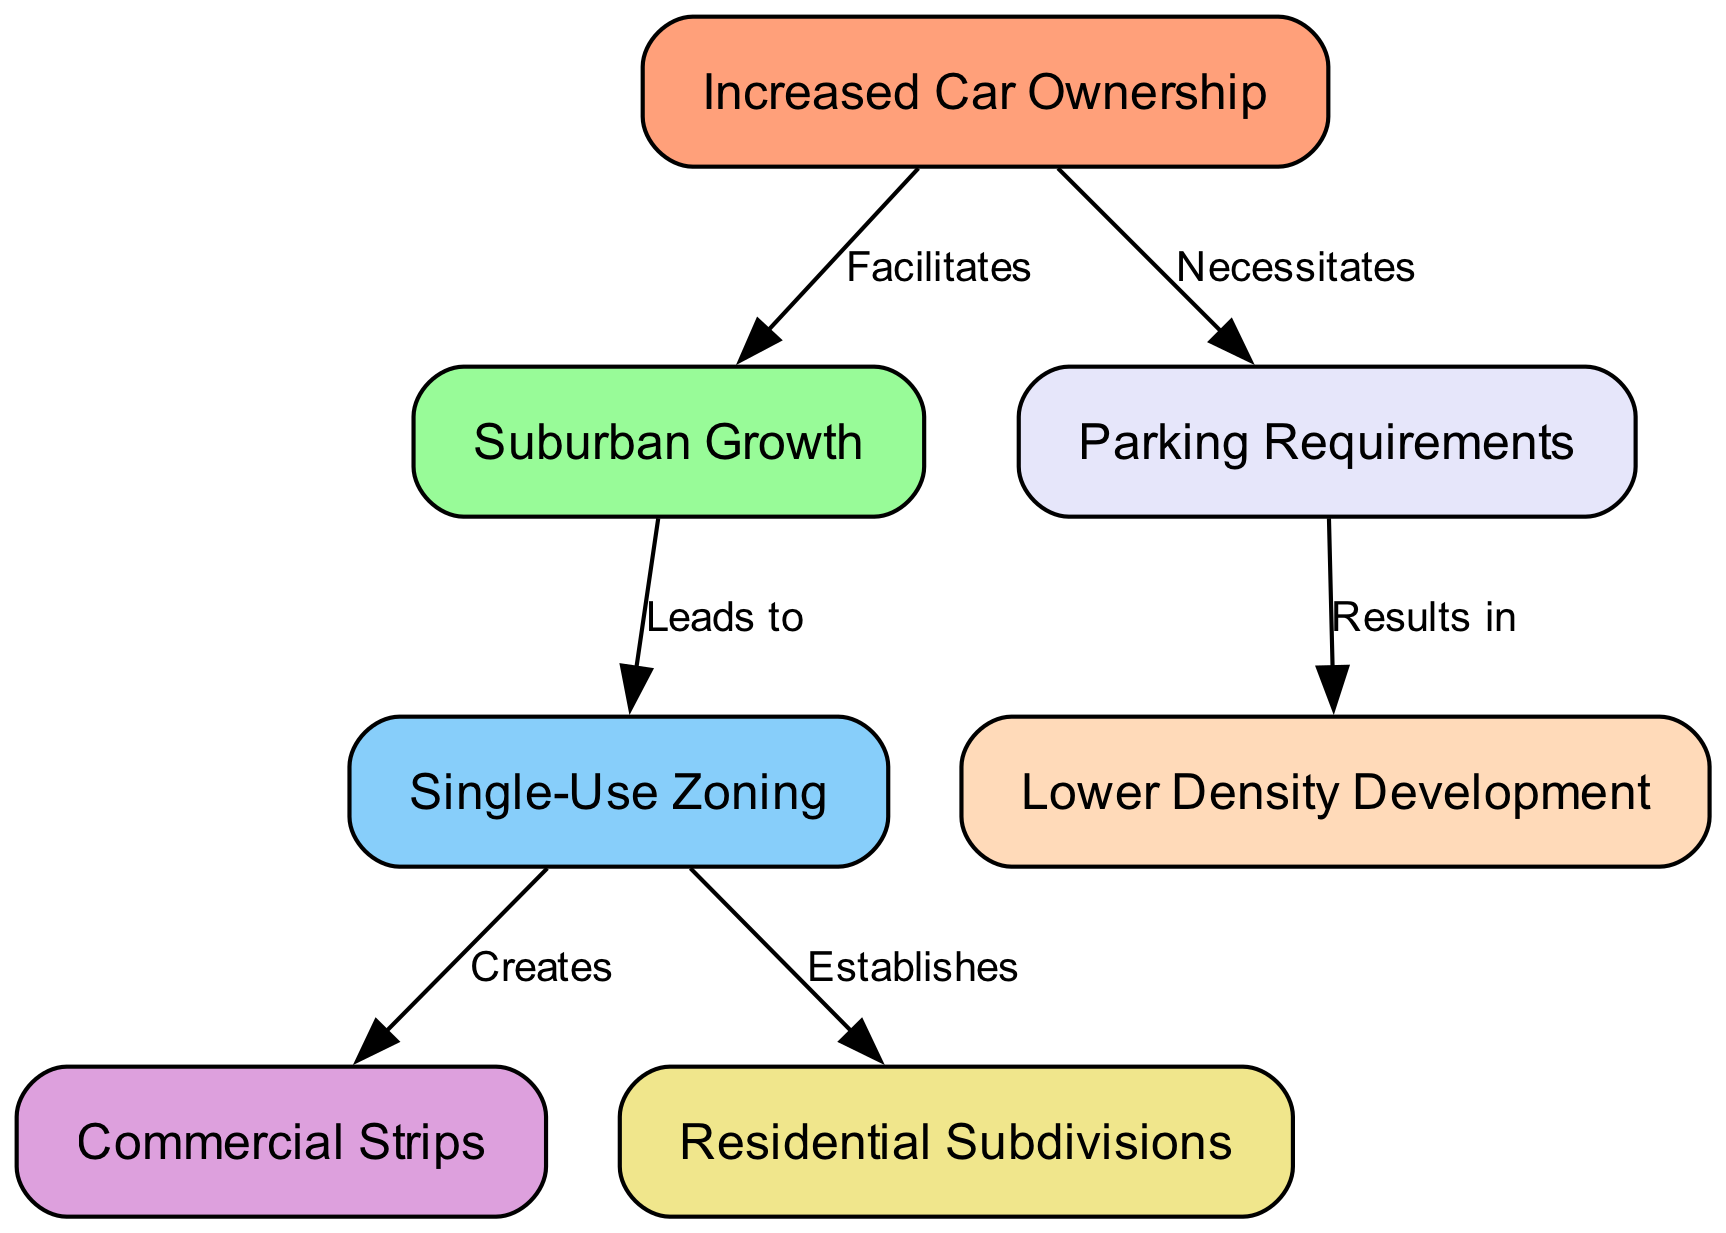What is the last node in the diagram? The last node is determined by tracing the directed edges starting from the first node. The edges from "Increased Car Ownership" lead to "Suburban Growth" which has edges leading to "Single-Use Zoning." This establishes connections to "Commercial Strips" and "Residential Subdivisions," but there's a separate connection from "Increased Car Ownership" to "Parking Requirements," which then leads to "Lower Density Development," making "Lower Density Development" the last node.
Answer: Lower Density Development How many nodes are there in the diagram? By counting the listed nodes in the data, we find the nodes: "Increased Car Ownership," "Suburban Growth," "Single-Use Zoning," "Commercial Strips," "Residential Subdivisions," "Parking Requirements," and "Lower Density Development." This totals up to seven distinct nodes.
Answer: 7 What type of zoning is created due to Single-Use Zoning? The connection from "Single-Use Zoning" has two edges leading to "Commercial Strips" and "Residential Subdivisions." Therefore, it creates both, but in this case, the question asks for one specific type. Since "Commercial Strips" is specifically mentioned as being created, it is the answer.
Answer: Commercial Strips What does increased car ownership facilitate? Starting from the node "Increased Car Ownership," there is a directed edge to the node "Suburban Growth," indicating that increased car ownership facilitates suburban growth directly.
Answer: Suburban Growth What results from the parking requirements? Tracing the edge leading from "Parking Requirements," we see it connects to "Lower Density Development," indicating that parking requirements result in this kind of development in the area influenced.
Answer: Lower Density Development Which node is linked by the most edges? Examining the connections, "Single-Use Zoning" connects to both "Commercial Strips" and "Residential Subdivisions," which signifies it has the most outgoing connections (or edges) in this diagram.
Answer: Single-Use Zoning What is established by Single-Use Zoning? Looking at the edges from "Single-Use Zoning," we find it directly leads to "Commercial Strips" and "Residential Subdivisions," indicating it establishes both types of zoning but in this case, we will ask for one: "Residential Subdivisions."
Answer: Residential Subdivisions What necessitates parking requirements? The flow of the diagram shows a direct connection from "Increased Car Ownership" to "Parking Requirements," indicating that it is increased car ownership that necessitates the requirement for parking.
Answer: Increased Car Ownership 